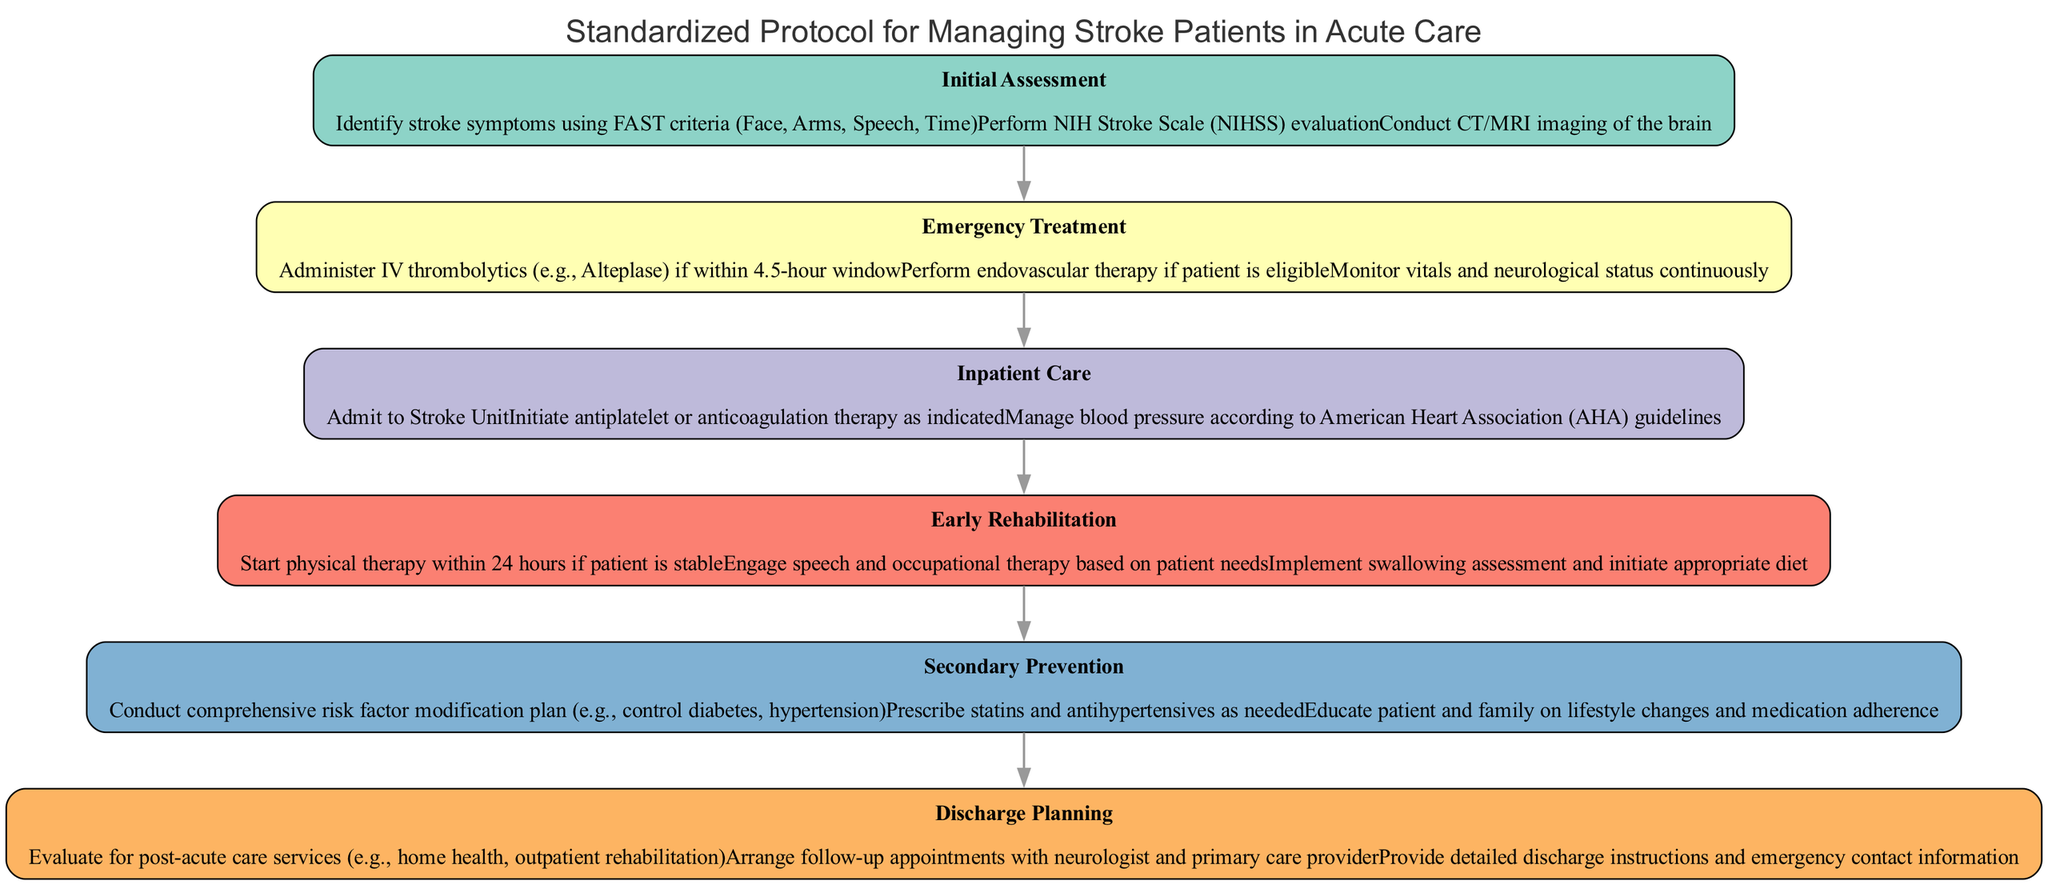What is the first stage in the pathway? The diagram lists the stages in order, starting with the first stage labeled "Initial Assessment."
Answer: Initial Assessment How many interventions are listed for Emergency Treatment? In the "Emergency Treatment" stage, there are three interventions specified: administering IV thrombolytics, performing endovascular therapy, and monitoring vitals, making a total of three.
Answer: 3 What intervention is performed if the patient is stable during Early Rehabilitation? The intervention listed for the "Early Rehabilitation" stage includes starting physical therapy within 24 hours if the patient is stable.
Answer: Start physical therapy What follows after Inpatient Care in the pathway? By examining the flow of the diagram, the stage that comes after "Inpatient Care" is "Early Rehabilitation."
Answer: Early Rehabilitation Which stage has the intervention regarding follow-up appointments? The intervention concerning follow-up appointments appears in the "Discharge Planning" stage, which includes arranging these appointments.
Answer: Discharge Planning How many total stages are indicated in the diagram? By counting each listed stage in the pathway, we find there are a total of six stages: Initial Assessment, Emergency Treatment, Inpatient Care, Early Rehabilitation, Secondary Prevention, and Discharge Planning.
Answer: 6 What is the main goal of the Secondary Prevention stage? The "Secondary Prevention" stage focuses on conducting a comprehensive risk factor modification plan, indicating it aims to prevent further strokes.
Answer: Risk factor modification If a patient is not eligible for endovascular therapy, which intervention should be prioritized next? If a patient is in the "Emergency Treatment" stage and not eligible for endovascular therapy, the next prioritized intervention remains monitoring vitals and neurological status continuously.
Answer: Monitor vitals and neurological status What type of assessment is implemented as part of Early Rehabilitation? In the "Early Rehabilitation" stage, a swallowing assessment is specifically mentioned, which helps determine appropriate diet measures for patients.
Answer: Swallowing assessment 